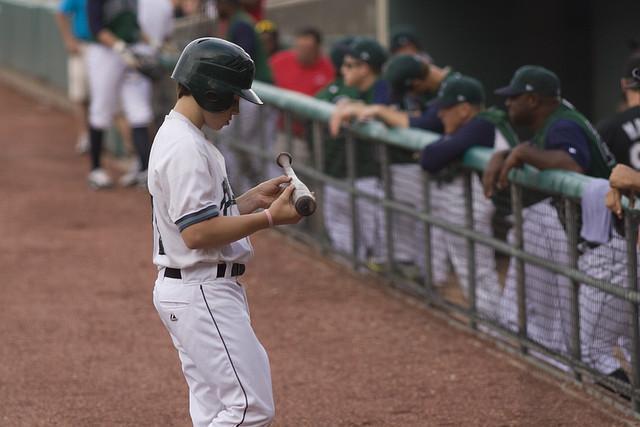What is the young man holding?
Answer the question by selecting the correct answer among the 4 following choices.
Options: Book, baseball bat, fish, fishing rod. Baseball bat. 